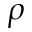<formula> <loc_0><loc_0><loc_500><loc_500>\rho</formula> 